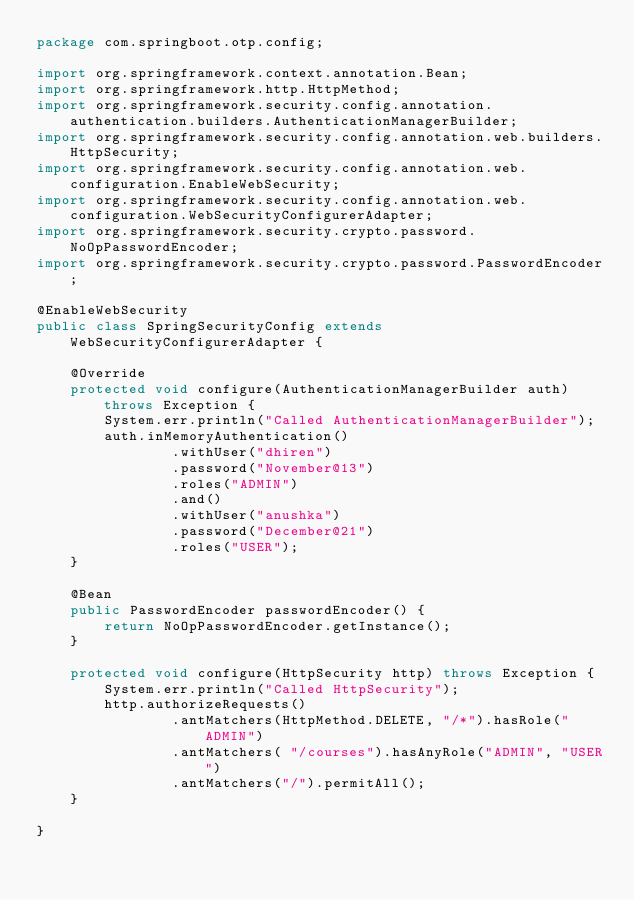<code> <loc_0><loc_0><loc_500><loc_500><_Java_>package com.springboot.otp.config;

import org.springframework.context.annotation.Bean;
import org.springframework.http.HttpMethod;
import org.springframework.security.config.annotation.authentication.builders.AuthenticationManagerBuilder;
import org.springframework.security.config.annotation.web.builders.HttpSecurity;
import org.springframework.security.config.annotation.web.configuration.EnableWebSecurity;
import org.springframework.security.config.annotation.web.configuration.WebSecurityConfigurerAdapter;
import org.springframework.security.crypto.password.NoOpPasswordEncoder;
import org.springframework.security.crypto.password.PasswordEncoder;

@EnableWebSecurity
public class SpringSecurityConfig extends WebSecurityConfigurerAdapter {

    @Override
    protected void configure(AuthenticationManagerBuilder auth) throws Exception {
        System.err.println("Called AuthenticationManagerBuilder");
        auth.inMemoryAuthentication()
                .withUser("dhiren")
                .password("November@13")
                .roles("ADMIN")
                .and()
                .withUser("anushka")
                .password("December@21")
                .roles("USER");
    }

    @Bean
    public PasswordEncoder passwordEncoder() {
        return NoOpPasswordEncoder.getInstance();
    }

    protected void configure(HttpSecurity http) throws Exception {
        System.err.println("Called HttpSecurity");
        http.authorizeRequests()
                .antMatchers(HttpMethod.DELETE, "/*").hasRole("ADMIN")
                .antMatchers( "/courses").hasAnyRole("ADMIN", "USER")
                .antMatchers("/").permitAll();
    }

}
</code> 